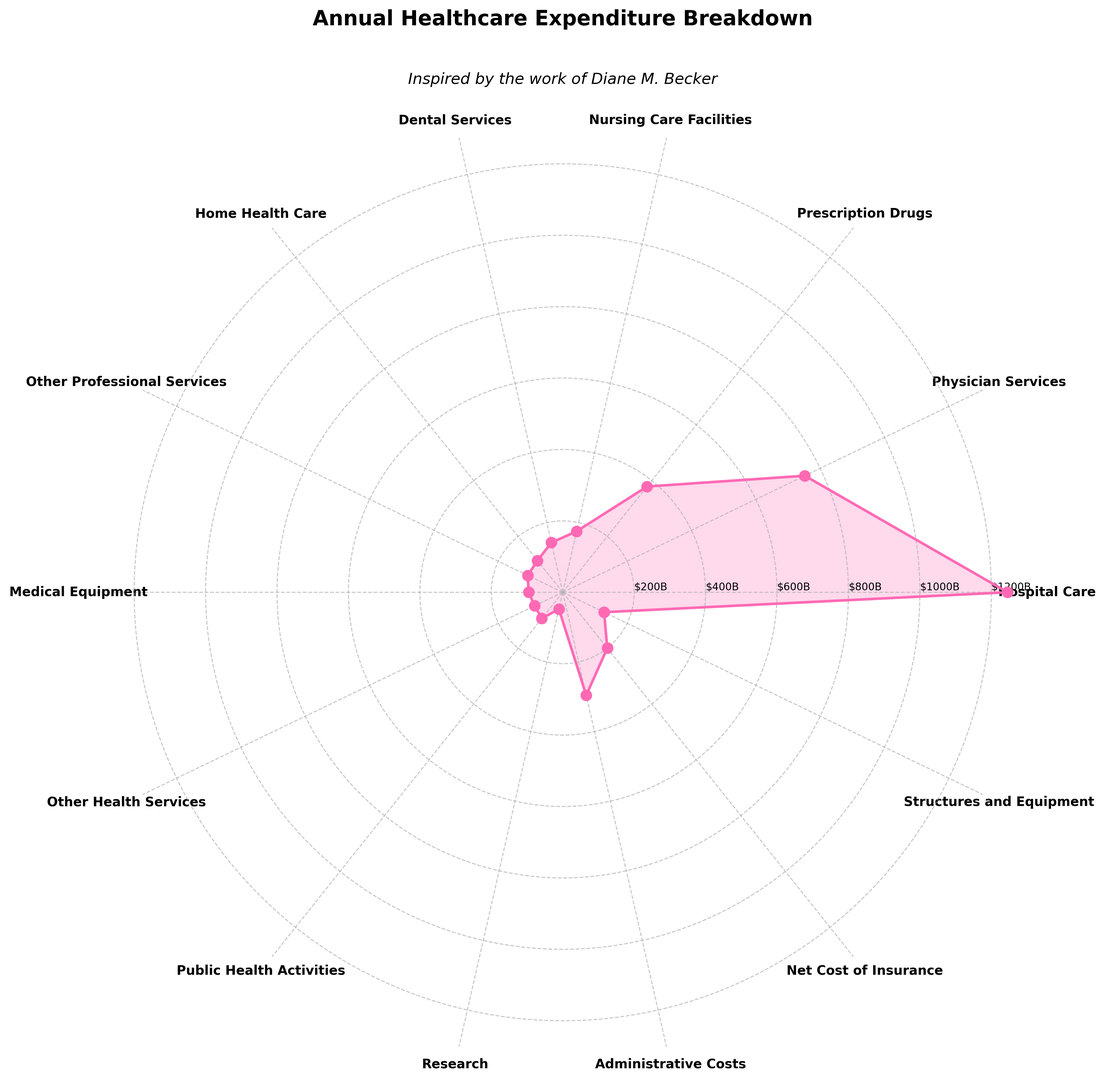What is the highest healthcare expenditure category? The figure shows multiple categories with varying expenditures, represented by different lengths on the rose chart. The largest value corresponds to the longest petal on the chart, which is "Hospital Care".
Answer: Hospital Care Which expenditure is larger: Physician Services or Dental Services? Locate the petals corresponding to "Physician Services" and "Dental Services". "Physician Services" has a longer petal than "Dental Services".
Answer: Physician Services What's the total expenditure for Prescription Drugs and Public Health Activities? Add the two expenditures by locating the lengths of the petals for "Prescription Drugs" ($378.9B) and "Public Health Activities" ($93.8B). The sum is $378.9B + $93.8B = $472.7B.
Answer: $472.7B What is the combined expenditure for Nursing Care Facilities and Administrative Costs? The expenditure for "Nursing Care Facilities" is $175.2B and for "Administrative Costs" is $295.7B. Add them to get $175.2B + $295.7B = $470.9B.
Answer: $470.9B How does the expenditure on Home Health Care compare to that on Medical Equipment? Compare the lengths of the petals for "Home Health Care" and "Medical Equipment". "Home Health Care" has a smaller expenditure of $113.5B compared to "Medical Equipment" which is $95.4B.
Answer: Home Health Care > Medical Equipment Which category has the smallest expenditure? Identify the shortest petal on the rose chart, which corresponds to "Research".
Answer: Research How much more is spent on the Net Cost of Insurance compared to Other Professional Services? The expenditure for "Net Cost of Insurance" is $200.1B and for "Other Professional Services" is $108.9B. Subtract the latter from the former: $200.1B - $108.9B = $91.2B.
Answer: $91.2B What's the sum of expenditures for Other Health Services, Structures and Equipment, and Research? Add up the expenditures for "Other Health Services" ($87.6B), "Structures and Equipment" ($128.5B), and "Research" ($48.3B): $87.6B + $128.5B + $48.3B = $264.4B.
Answer: $264.4B If you wanted to advocate for more funding in one of the lowest expense categories, which two would you choose and why? Identify the categories with the shortest petals on the rose chart: "Research" and "Home Health Care". They represent the smallest expenditures, making them logical candidates for increased funding.
Answer: Research and Home Health Care What's the difference in expenditure between Hospital Care and Home Health Care? The expenditure for "Hospital Care" is $1245.6B and for "Home Health Care" is $113.5B. The difference is $1245.6B - $113.5B = $1132.1B.
Answer: $1132.1B 